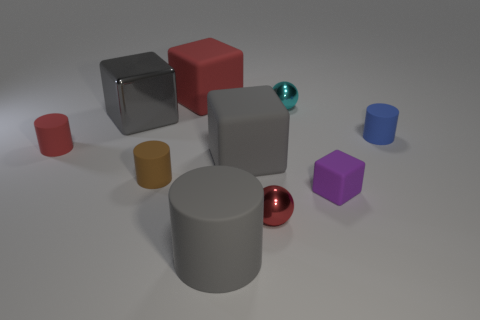Subtract all green cylinders. How many gray blocks are left? 2 Subtract all tiny red cylinders. How many cylinders are left? 3 Subtract all balls. How many objects are left? 8 Subtract 1 balls. How many balls are left? 1 Subtract all red spheres. How many spheres are left? 1 Subtract all blue balls. Subtract all green blocks. How many balls are left? 2 Subtract all red metal balls. Subtract all small red rubber cylinders. How many objects are left? 8 Add 1 tiny rubber blocks. How many tiny rubber blocks are left? 2 Add 4 blue metal objects. How many blue metal objects exist? 4 Subtract 1 red cylinders. How many objects are left? 9 